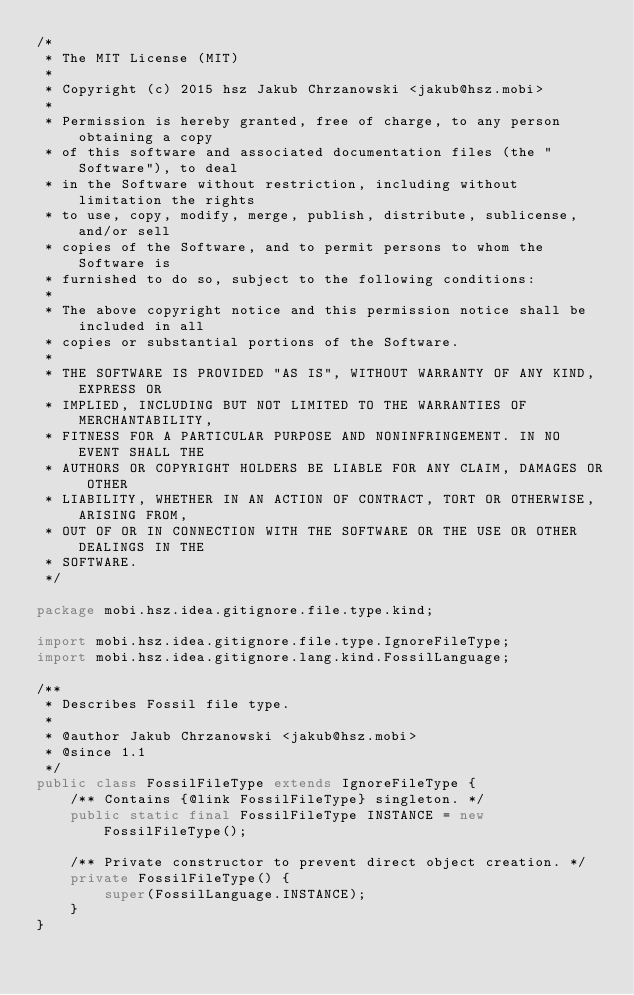Convert code to text. <code><loc_0><loc_0><loc_500><loc_500><_Java_>/*
 * The MIT License (MIT)
 *
 * Copyright (c) 2015 hsz Jakub Chrzanowski <jakub@hsz.mobi>
 *
 * Permission is hereby granted, free of charge, to any person obtaining a copy
 * of this software and associated documentation files (the "Software"), to deal
 * in the Software without restriction, including without limitation the rights
 * to use, copy, modify, merge, publish, distribute, sublicense, and/or sell
 * copies of the Software, and to permit persons to whom the Software is
 * furnished to do so, subject to the following conditions:
 *
 * The above copyright notice and this permission notice shall be included in all
 * copies or substantial portions of the Software.
 *
 * THE SOFTWARE IS PROVIDED "AS IS", WITHOUT WARRANTY OF ANY KIND, EXPRESS OR
 * IMPLIED, INCLUDING BUT NOT LIMITED TO THE WARRANTIES OF MERCHANTABILITY,
 * FITNESS FOR A PARTICULAR PURPOSE AND NONINFRINGEMENT. IN NO EVENT SHALL THE
 * AUTHORS OR COPYRIGHT HOLDERS BE LIABLE FOR ANY CLAIM, DAMAGES OR OTHER
 * LIABILITY, WHETHER IN AN ACTION OF CONTRACT, TORT OR OTHERWISE, ARISING FROM,
 * OUT OF OR IN CONNECTION WITH THE SOFTWARE OR THE USE OR OTHER DEALINGS IN THE
 * SOFTWARE.
 */

package mobi.hsz.idea.gitignore.file.type.kind;

import mobi.hsz.idea.gitignore.file.type.IgnoreFileType;
import mobi.hsz.idea.gitignore.lang.kind.FossilLanguage;

/**
 * Describes Fossil file type.
 *
 * @author Jakub Chrzanowski <jakub@hsz.mobi>
 * @since 1.1
 */
public class FossilFileType extends IgnoreFileType {
    /** Contains {@link FossilFileType} singleton. */
    public static final FossilFileType INSTANCE = new FossilFileType();

    /** Private constructor to prevent direct object creation. */
    private FossilFileType() {
        super(FossilLanguage.INSTANCE);
    }
}
</code> 